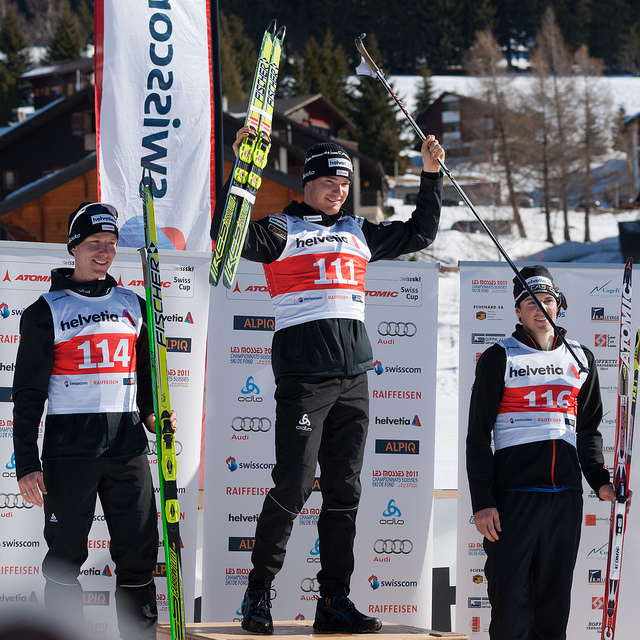Read all the text in this image. A nocssiws 111 helvetia helvetia 114 ATOMIC helvetia 116 Cup swisscom EISEM vetia LPIQ IFFEISEN swisscom FISCHER LPIQ Cup Swiss vetia 2011 RAIF hel ATOMI Audi Aro ALPIQ odlo Audi RAIFFEISE helveti ALI CX RAIFFEISEN swisscom AUDI ALPIQ helvetia RAIFFEISEN swisscom TOMIC 